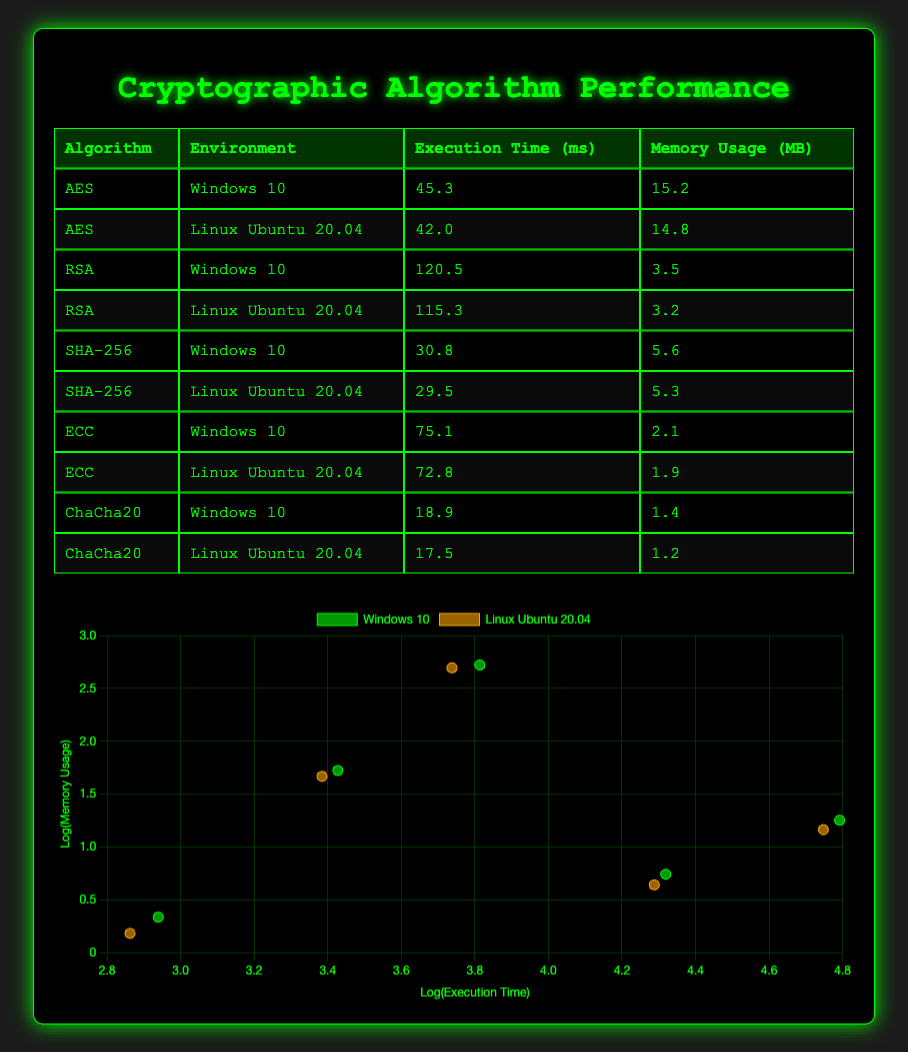What is the execution time of AES in Linux Ubuntu 20.04? The execution time of AES in Linux Ubuntu 20.04 is listed directly in the table under the corresponding environment, which states it as 42.0 ms.
Answer: 42.0 ms Which cryptographic algorithm has the highest memory usage in Windows 10? Reviewing the table, AES shows the highest memory usage in Windows 10 at 15.2 MB.
Answer: AES What is the average execution time for RSA across both environments? To find the average execution time for RSA, we first sum the execution times: 120.5 ms (Windows 10) + 115.3 ms (Linux Ubuntu 20.04) = 235.8 ms. Then, we divide by the number of values (2), giving us an average of 235.8 ms / 2 = 117.9 ms.
Answer: 117.9 ms Is the memory usage of ChaCha20 lower than that of ECC in both operating environments? Looking at the table: In Windows 10, ChaCha20 has 1.4 MB and ECC has 2.1 MB; therefore, ChaCha20 is lower. In Linux Ubuntu 20.04, ChaCha20 has 1.2 MB and ECC has 1.9 MB; thus, ChaCha20 is also lower here. Hence, the answer is yes.
Answer: Yes What is the difference in execution time between ECC on Windows 10 and Linux Ubuntu 20.04? The execution time for ECC on Windows 10 is 75.1 ms and on Linux Ubuntu 20.04 it is 72.8 ms. To find the difference, we subtract: 75.1 ms - 72.8 ms = 2.3 ms.
Answer: 2.3 ms Which algorithm has the lowest execution time in Linux Ubuntu 20.04? The table shows that ChaCha20, with an execution time of 17.5 ms, has the lowest execution time in Linux Ubuntu 20.04 when compared to other algorithms in that environment.
Answer: ChaCha20 Is there any algorithm that has a higher memory usage in Linux Ubuntu 20.04 compared to its usage in Windows 10? By comparing the memory usages: AES (14.8 MB vs 15.2 MB), RSA (3.2 MB vs 3.5 MB), SHA-256 (5.3 MB vs 5.6 MB), ECC (1.9 MB vs 2.1 MB), and ChaCha20 (1.2 MB vs 1.4 MB), none of these algorithms show an increase in memory usage in Linux over Windows, so the answer is no.
Answer: No Calculate the total execution time for all algorithms in Windows 10. We can sum the execution times of all algorithms in Windows 10: 45.3 ms (AES) + 120.5 ms (RSA) + 30.8 ms (SHA-256) + 75.1 ms (ECC) + 18.9 ms (ChaCha20) = 290.6 ms total.
Answer: 290.6 ms Which environment shows better overall performance (lower execution time) for the SHA-256 algorithm? The execution time for SHA-256 in Windows 10 is 30.8 ms, while in Linux Ubuntu 20.04 it is 29.5 ms. Since 29.5 ms is less than 30.8 ms, Linux Ubuntu 20.04 demonstrates better performance for the SHA-256 algorithm.
Answer: Linux Ubuntu 20.04 